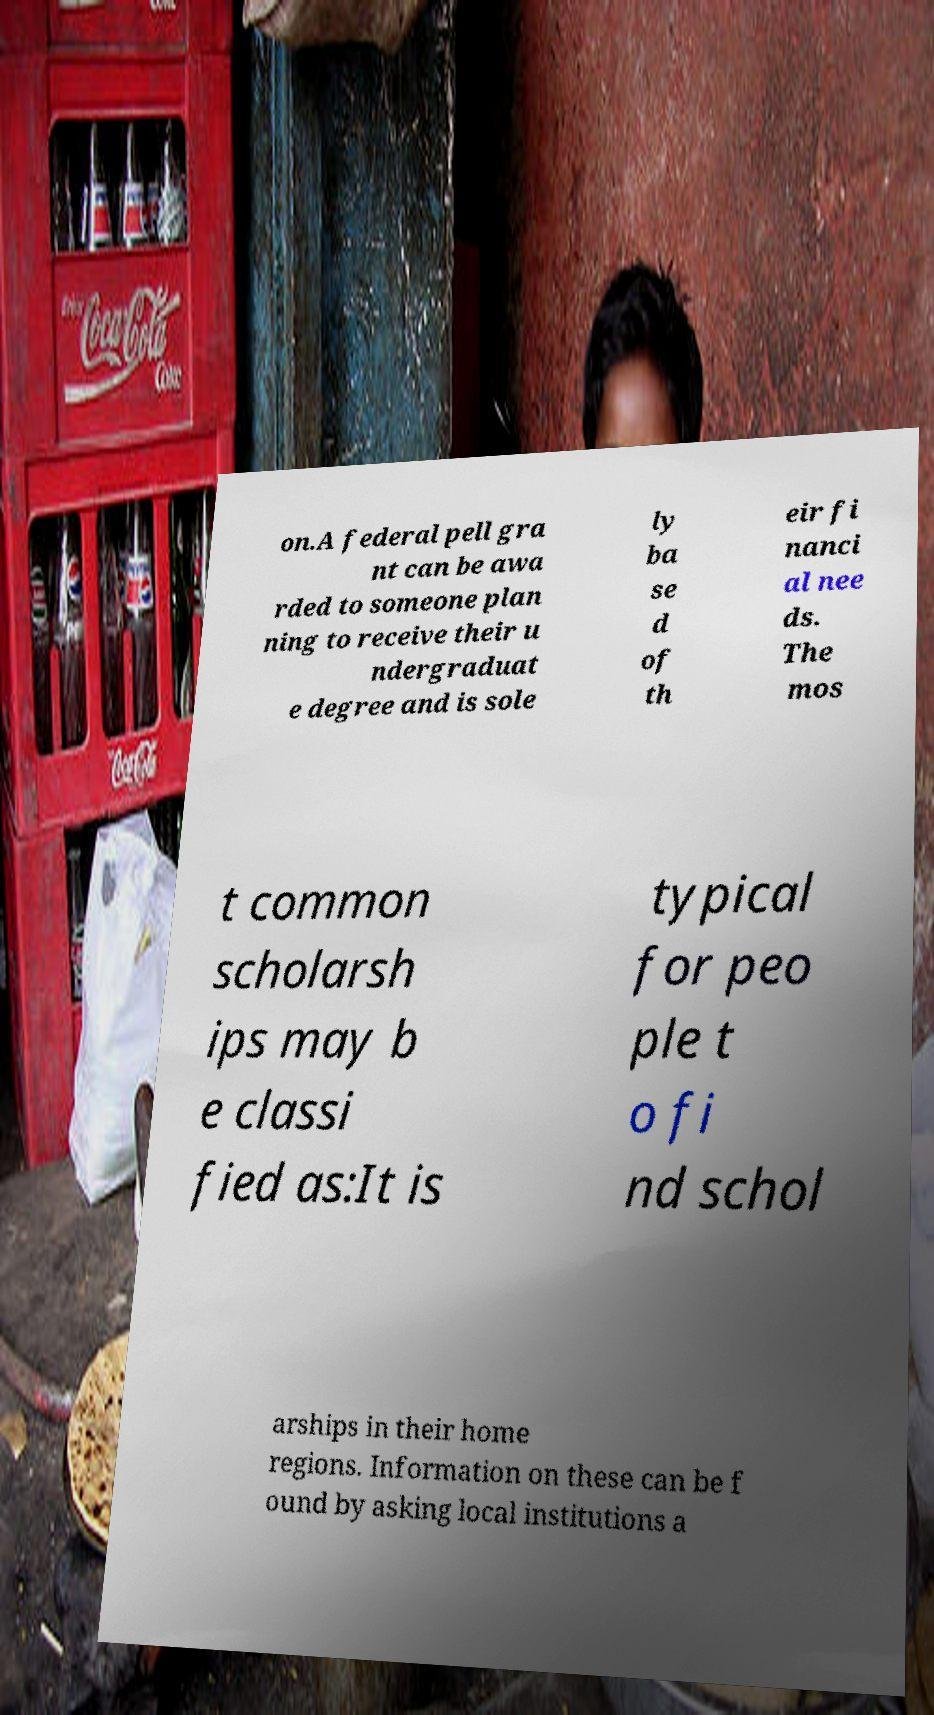Please identify and transcribe the text found in this image. on.A federal pell gra nt can be awa rded to someone plan ning to receive their u ndergraduat e degree and is sole ly ba se d of th eir fi nanci al nee ds. The mos t common scholarsh ips may b e classi fied as:It is typical for peo ple t o fi nd schol arships in their home regions. Information on these can be f ound by asking local institutions a 